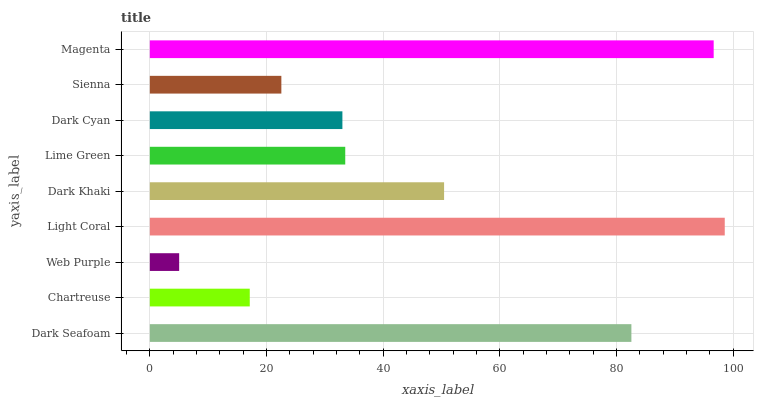Is Web Purple the minimum?
Answer yes or no. Yes. Is Light Coral the maximum?
Answer yes or no. Yes. Is Chartreuse the minimum?
Answer yes or no. No. Is Chartreuse the maximum?
Answer yes or no. No. Is Dark Seafoam greater than Chartreuse?
Answer yes or no. Yes. Is Chartreuse less than Dark Seafoam?
Answer yes or no. Yes. Is Chartreuse greater than Dark Seafoam?
Answer yes or no. No. Is Dark Seafoam less than Chartreuse?
Answer yes or no. No. Is Lime Green the high median?
Answer yes or no. Yes. Is Lime Green the low median?
Answer yes or no. Yes. Is Light Coral the high median?
Answer yes or no. No. Is Dark Khaki the low median?
Answer yes or no. No. 